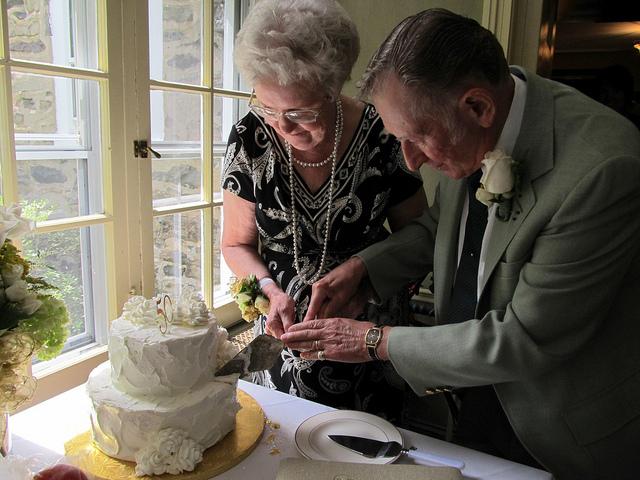What are they celebrating?
Quick response, please. Anniversary. Is the man wearing formal clothes?
Keep it brief. Yes. What are they cutting into?
Give a very brief answer. Cake. Are these two married?
Keep it brief. Yes. What do the people have on their hands?
Give a very brief answer. Rings. What are the people holding?
Be succinct. Knife. 